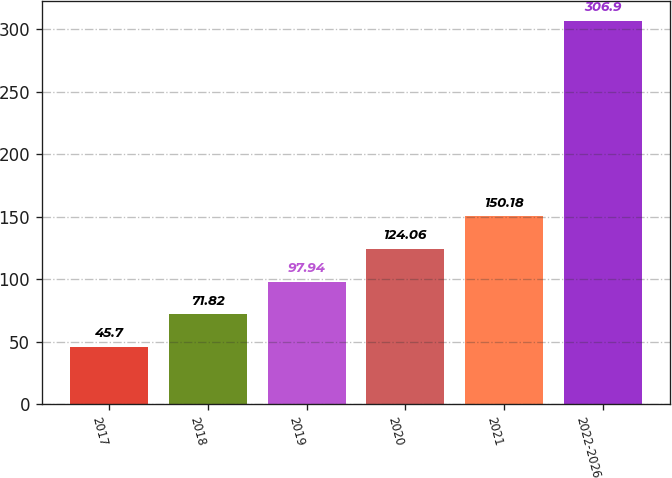Convert chart to OTSL. <chart><loc_0><loc_0><loc_500><loc_500><bar_chart><fcel>2017<fcel>2018<fcel>2019<fcel>2020<fcel>2021<fcel>2022-2026<nl><fcel>45.7<fcel>71.82<fcel>97.94<fcel>124.06<fcel>150.18<fcel>306.9<nl></chart> 